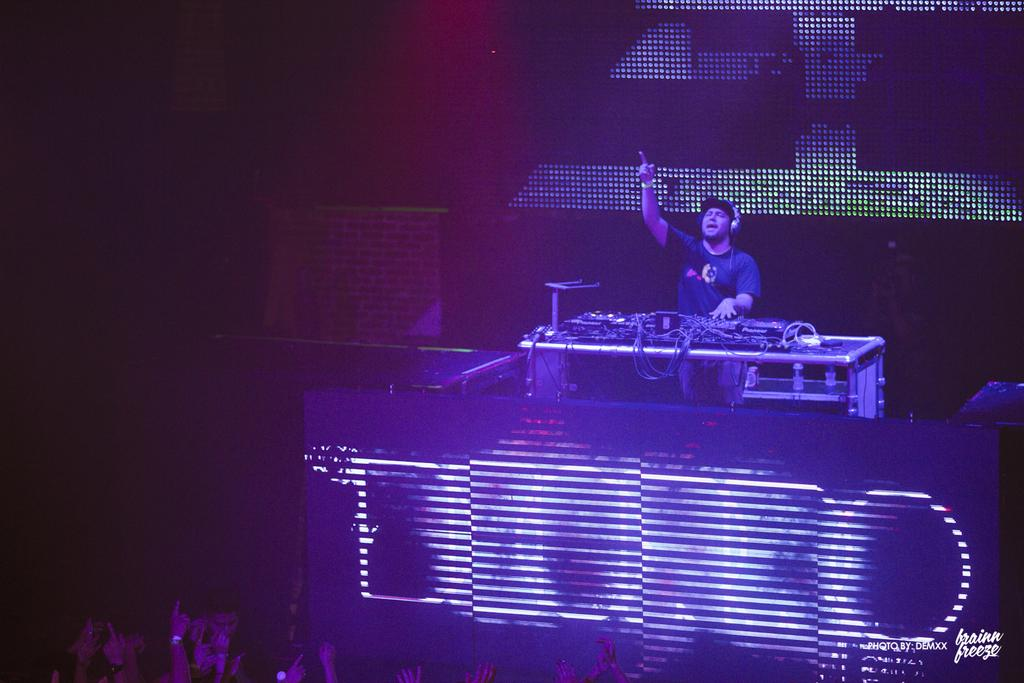What type of event is taking place in the image? It is a concert. What is the man in the image doing? The man is playing music. How is the man connected to the sound system? The man is wearing a headset. What can be seen in front of the man? There are LED lights in front of the man. How is the crowd reacting to the music? The crowd is enjoying the music. How much money does the man lose during the concert? There is no information about money or any loss in the image. The focus is on the concert, the man playing music, and the crowd's enjoyment. 